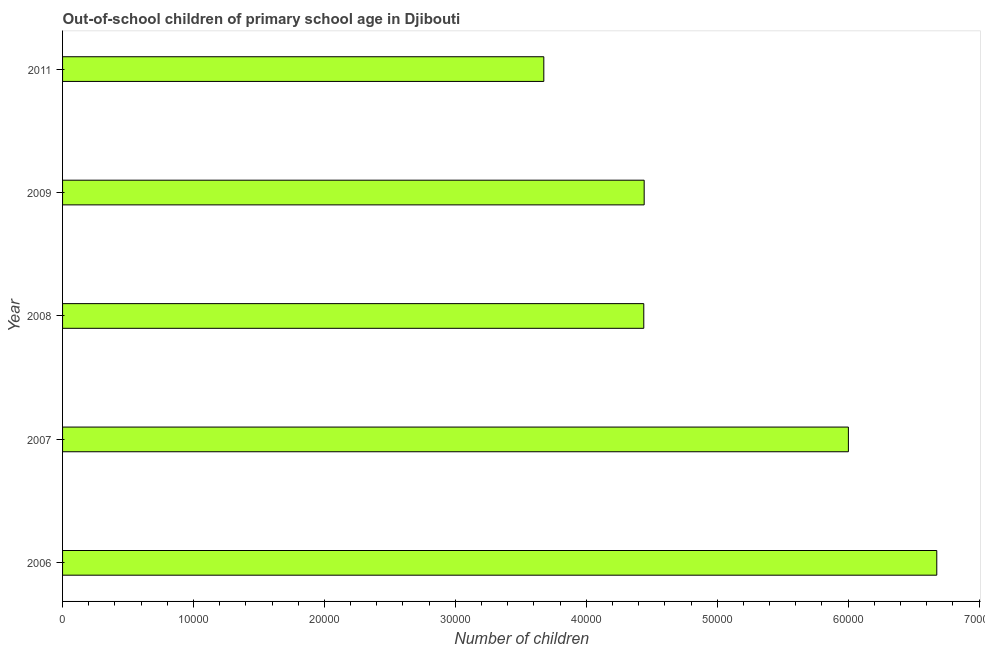Does the graph contain any zero values?
Keep it short and to the point. No. Does the graph contain grids?
Your response must be concise. No. What is the title of the graph?
Provide a short and direct response. Out-of-school children of primary school age in Djibouti. What is the label or title of the X-axis?
Make the answer very short. Number of children. What is the label or title of the Y-axis?
Offer a very short reply. Year. What is the number of out-of-school children in 2009?
Keep it short and to the point. 4.44e+04. Across all years, what is the maximum number of out-of-school children?
Give a very brief answer. 6.68e+04. Across all years, what is the minimum number of out-of-school children?
Keep it short and to the point. 3.68e+04. In which year was the number of out-of-school children minimum?
Ensure brevity in your answer.  2011. What is the sum of the number of out-of-school children?
Ensure brevity in your answer.  2.52e+05. What is the average number of out-of-school children per year?
Give a very brief answer. 5.05e+04. What is the median number of out-of-school children?
Give a very brief answer. 4.44e+04. In how many years, is the number of out-of-school children greater than 22000 ?
Provide a succinct answer. 5. Is the difference between the number of out-of-school children in 2006 and 2007 greater than the difference between any two years?
Provide a succinct answer. No. What is the difference between the highest and the second highest number of out-of-school children?
Provide a short and direct response. 6751. Is the sum of the number of out-of-school children in 2008 and 2011 greater than the maximum number of out-of-school children across all years?
Provide a succinct answer. Yes. What is the difference between the highest and the lowest number of out-of-school children?
Give a very brief answer. 3.00e+04. How many bars are there?
Give a very brief answer. 5. Are all the bars in the graph horizontal?
Offer a terse response. Yes. What is the Number of children of 2006?
Provide a succinct answer. 6.68e+04. What is the Number of children in 2007?
Your response must be concise. 6.00e+04. What is the Number of children in 2008?
Offer a very short reply. 4.44e+04. What is the Number of children in 2009?
Offer a terse response. 4.44e+04. What is the Number of children of 2011?
Your answer should be very brief. 3.68e+04. What is the difference between the Number of children in 2006 and 2007?
Offer a very short reply. 6751. What is the difference between the Number of children in 2006 and 2008?
Ensure brevity in your answer.  2.24e+04. What is the difference between the Number of children in 2006 and 2009?
Make the answer very short. 2.23e+04. What is the difference between the Number of children in 2006 and 2011?
Your answer should be very brief. 3.00e+04. What is the difference between the Number of children in 2007 and 2008?
Make the answer very short. 1.56e+04. What is the difference between the Number of children in 2007 and 2009?
Provide a succinct answer. 1.56e+04. What is the difference between the Number of children in 2007 and 2011?
Keep it short and to the point. 2.33e+04. What is the difference between the Number of children in 2008 and 2009?
Ensure brevity in your answer.  -30. What is the difference between the Number of children in 2008 and 2011?
Offer a terse response. 7635. What is the difference between the Number of children in 2009 and 2011?
Your answer should be compact. 7665. What is the ratio of the Number of children in 2006 to that in 2007?
Provide a short and direct response. 1.11. What is the ratio of the Number of children in 2006 to that in 2008?
Your answer should be very brief. 1.5. What is the ratio of the Number of children in 2006 to that in 2009?
Provide a succinct answer. 1.5. What is the ratio of the Number of children in 2006 to that in 2011?
Your answer should be compact. 1.82. What is the ratio of the Number of children in 2007 to that in 2008?
Your answer should be very brief. 1.35. What is the ratio of the Number of children in 2007 to that in 2009?
Ensure brevity in your answer.  1.35. What is the ratio of the Number of children in 2007 to that in 2011?
Keep it short and to the point. 1.63. What is the ratio of the Number of children in 2008 to that in 2009?
Your response must be concise. 1. What is the ratio of the Number of children in 2008 to that in 2011?
Make the answer very short. 1.21. What is the ratio of the Number of children in 2009 to that in 2011?
Ensure brevity in your answer.  1.21. 